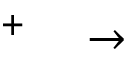<formula> <loc_0><loc_0><loc_500><loc_500>^ { + } \quad \rightarrow</formula> 